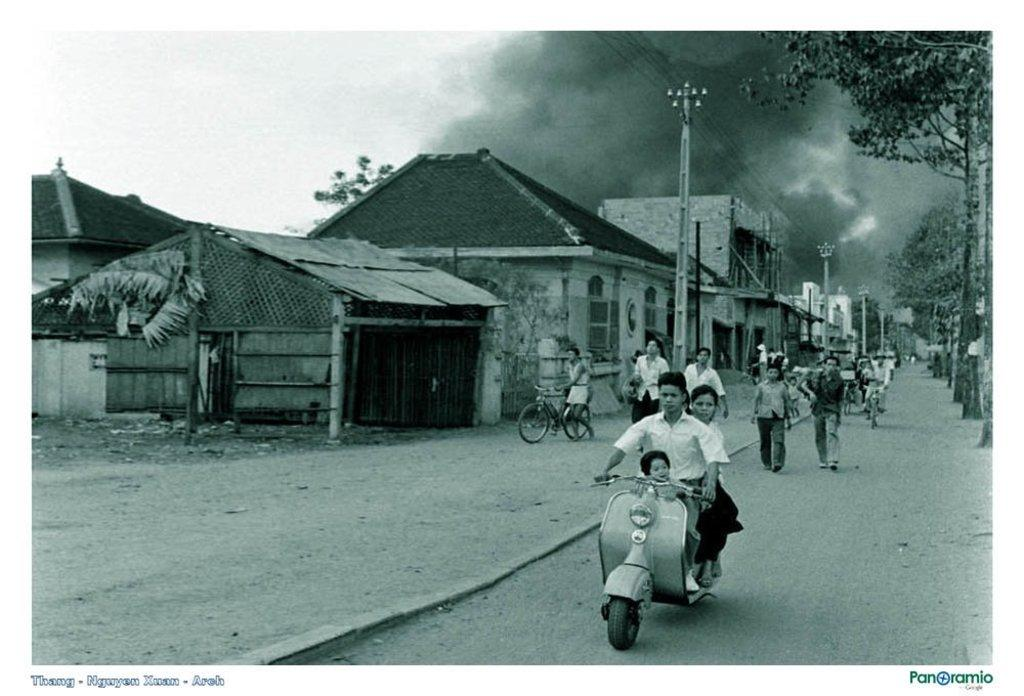What type of structures can be seen in the image? There are houses in the image. What other objects are present in the image? There are current poles, trees, bicycles, and a motorcycle in the image. Are there any living beings in the image? Yes, there are people in the image. What is visible in the background of the image? The sky is visible in the image, and clouds are present in the sky. What type of duck can be seen wearing a sweater in the image? There is no duck or sweater present in the image. What kind of noise can be heard coming from the motorcycle in the image? The image is static, so no noise can be heard from the motorcycle. 